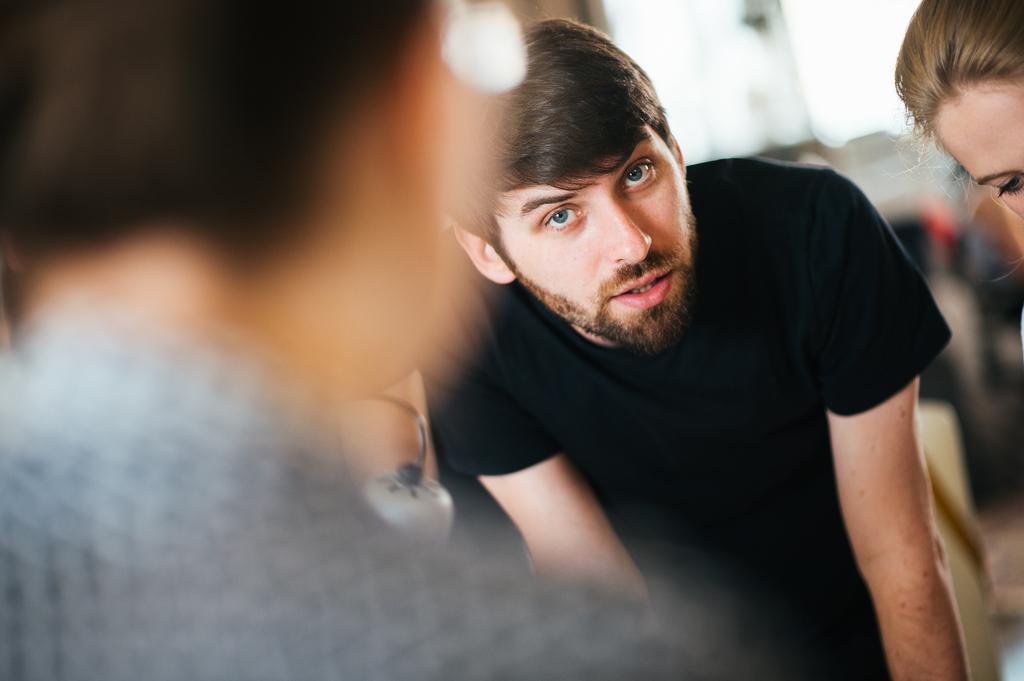What can be seen in the image? There are people in the image. Can you describe the quality of the image? The image is blurry. What color is the tongue of the person in the image? There is no tongue visible in the image, as it is blurry and does not show any specific details about the people. 